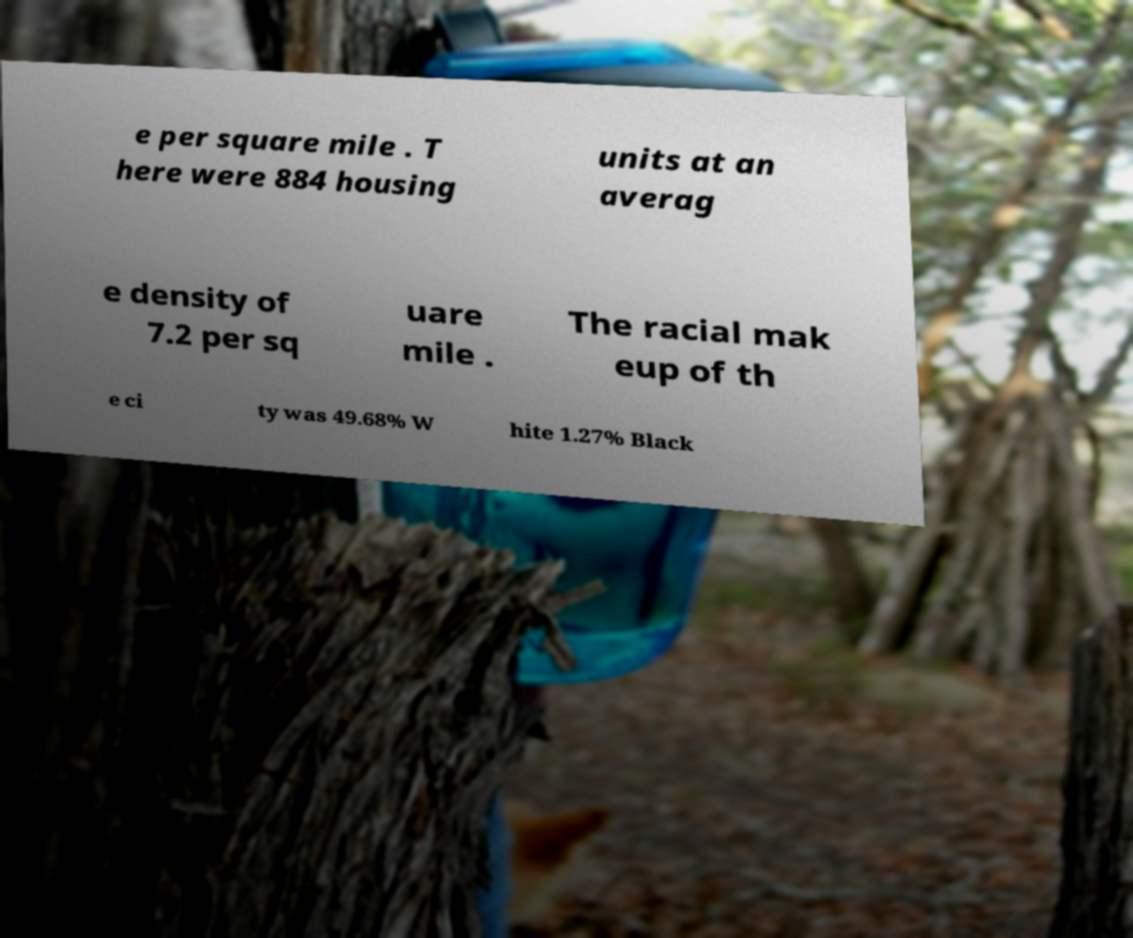Please read and relay the text visible in this image. What does it say? e per square mile . T here were 884 housing units at an averag e density of 7.2 per sq uare mile . The racial mak eup of th e ci ty was 49.68% W hite 1.27% Black 